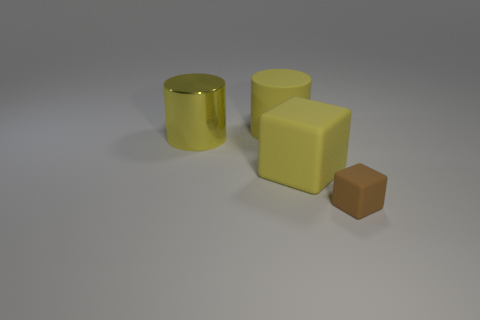What materials do the objects in the image seem to be made of? Based on the visual cues, the yellow cylindrical object and the smallest cube appear to have a shiny, reflective surface, suggesting they could be made of a polished, rubber-like material. On the other hand, the brown cube has a matte finish that might indicate a different, more textured material, such as a type of plastic or possibly wood. 